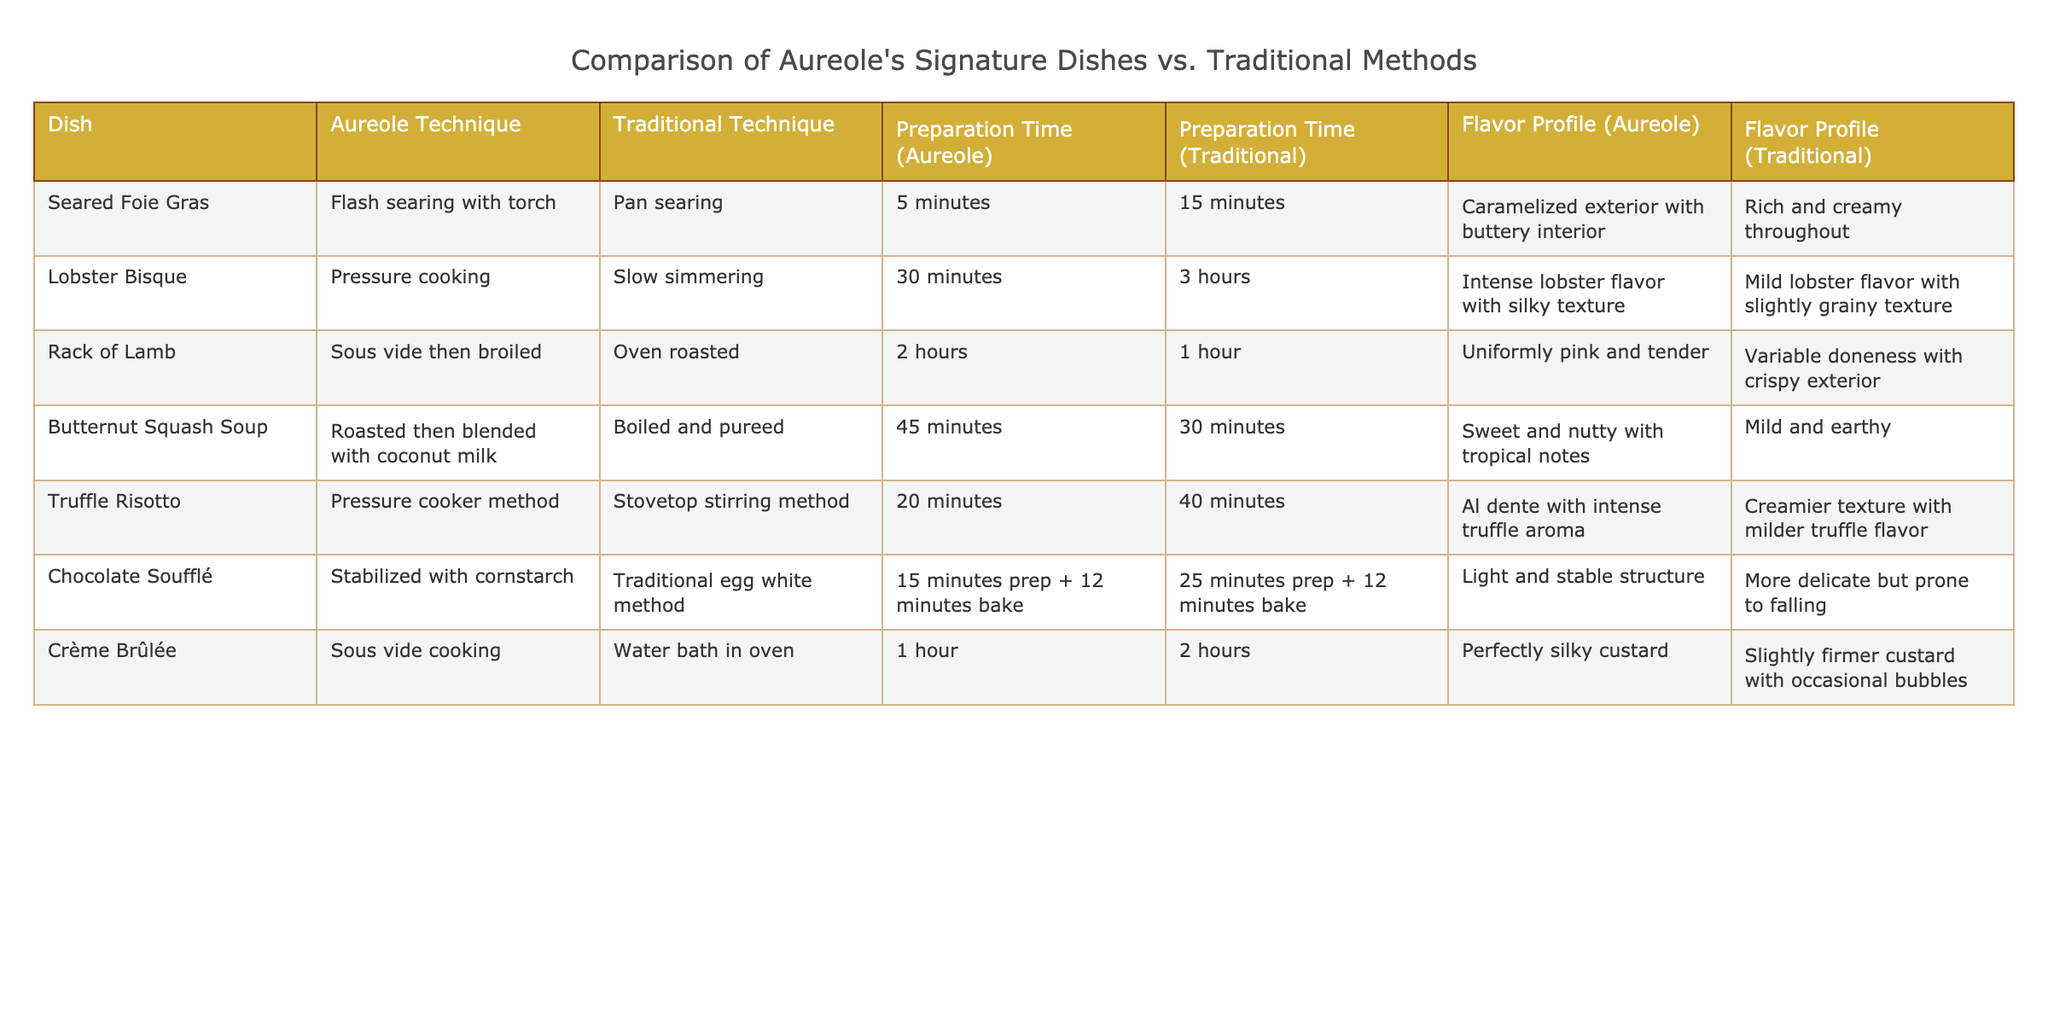What cooking technique is used for Seared Foie Gras at Aureole? The table specifies that Aureole uses "Flash searing with torch" for the Seared Foie Gras dish.
Answer: Flash searing with torch What is the preparation time difference between Lobster Bisque using Aureole's technique and the traditional method? The preparation time for Lobster Bisque using Aureole's technique is 30 minutes, while the traditional method takes 3 hours. The difference is 3 hours (180 minutes) - 30 minutes = 150 minutes.
Answer: 150 minutes Is the flavor profile of the Chocolate Soufflé at Aureole lighter than the traditional method? According to the table, Aureole's Chocolate Soufflé has a "Light and stable structure", while the traditional method is described as "More delicate but prone to falling". This indicates Aureole's version is indeed lighter.
Answer: Yes Which dish has the longest preparation time using Aureole's technique? By examining the preparation times for each dish using Aureole's technique, the longest time is for Rack of Lamb at 2 hours.
Answer: Rack of Lamb What is the flavor profile of Butternut Squash Soup using Aureole's technique? The table notes that the flavor profile for Butternut Squash Soup at Aureole is "Sweet and nutty with tropical notes."
Answer: Sweet and nutty with tropical notes If we compare the preparation times of Crème Brûlée between the two methods, how much longer does the traditional method take? The preparation time for Crème Brûlée using Aureole's technique is 1 hour, while the traditional method takes 2 hours. The difference is 2 hours - 1 hour = 1 hour.
Answer: 1 hour Is the intense flavor profile of Lobster Bisque unique to Aureole's method? The table indicates that Aureole's Lobster Bisque has an "Intense lobster flavor with silky texture," whereas the traditional method has a "Mild lobster flavor with slightly grainy texture." Thus, Aureole's method provides a unique flavor profile.
Answer: Yes Which dish at Aureole features pressure cooking as a technique and how does its preparation time compare to traditional methods? The dishes that use pressure cooking as per the table are Lobster Bisque and Truffle Risotto. Their preparation times are 30 minutes and 20 minutes respectively, and both are significantly shorter than their traditional counterparts.
Answer: Lobster Bisque and Truffle Risotto; both take less time What can be inferred about the complexity of the cooking technique for Rack of Lamb compared to traditional oven roasting? The table indicates that Aureole uses "Sous vide then broiled" for Rack of Lamb, which is more complex than traditional oven roasting, as it involves more precise control over cooking temperatures and times.
Answer: More complex What percentage of the dishes listed have a preparation time shorter than 1 hour using Aureole's techniques? There are 7 dishes total. The dishes with preparation times shorter than 1 hour using Aureole methods are Seared Foie Gras (5 minutes), Truffle Risotto (20 minutes), Chocolate Soufflé (15 minutes), and Crème Brûlée (1 hour). That's 4 out of 7, or approximately 57.14%.
Answer: Approximately 57.14% 